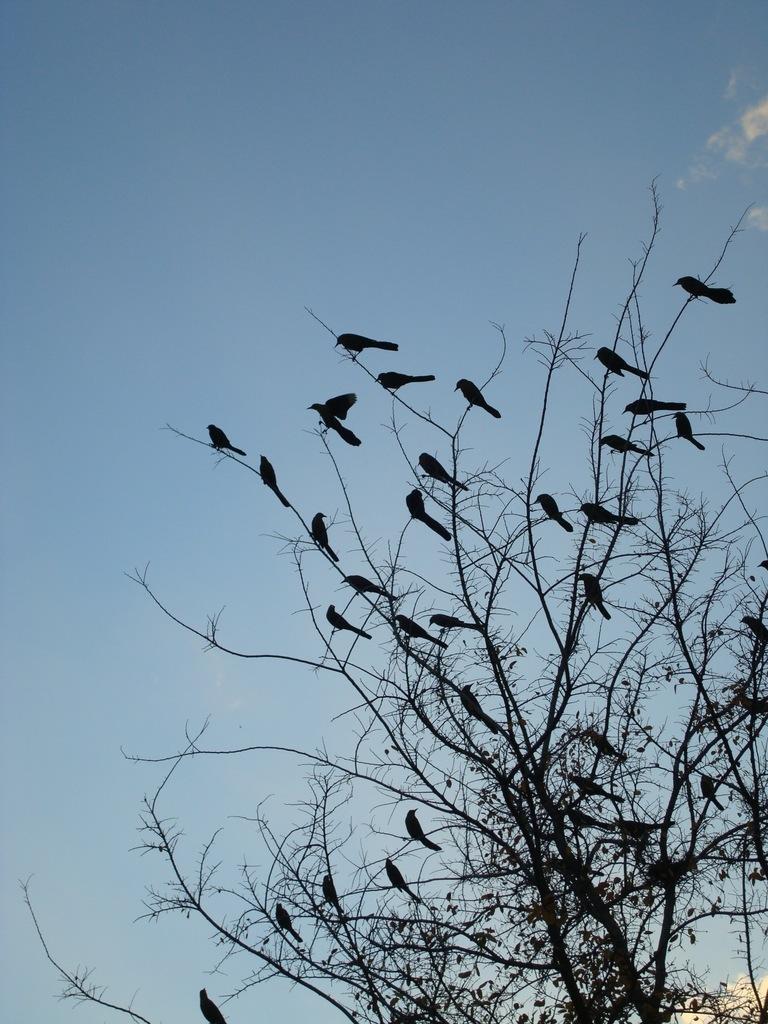In one or two sentences, can you explain what this image depicts? In this picture I can see birds on the branches of a tree, and in the background there is the sky. 